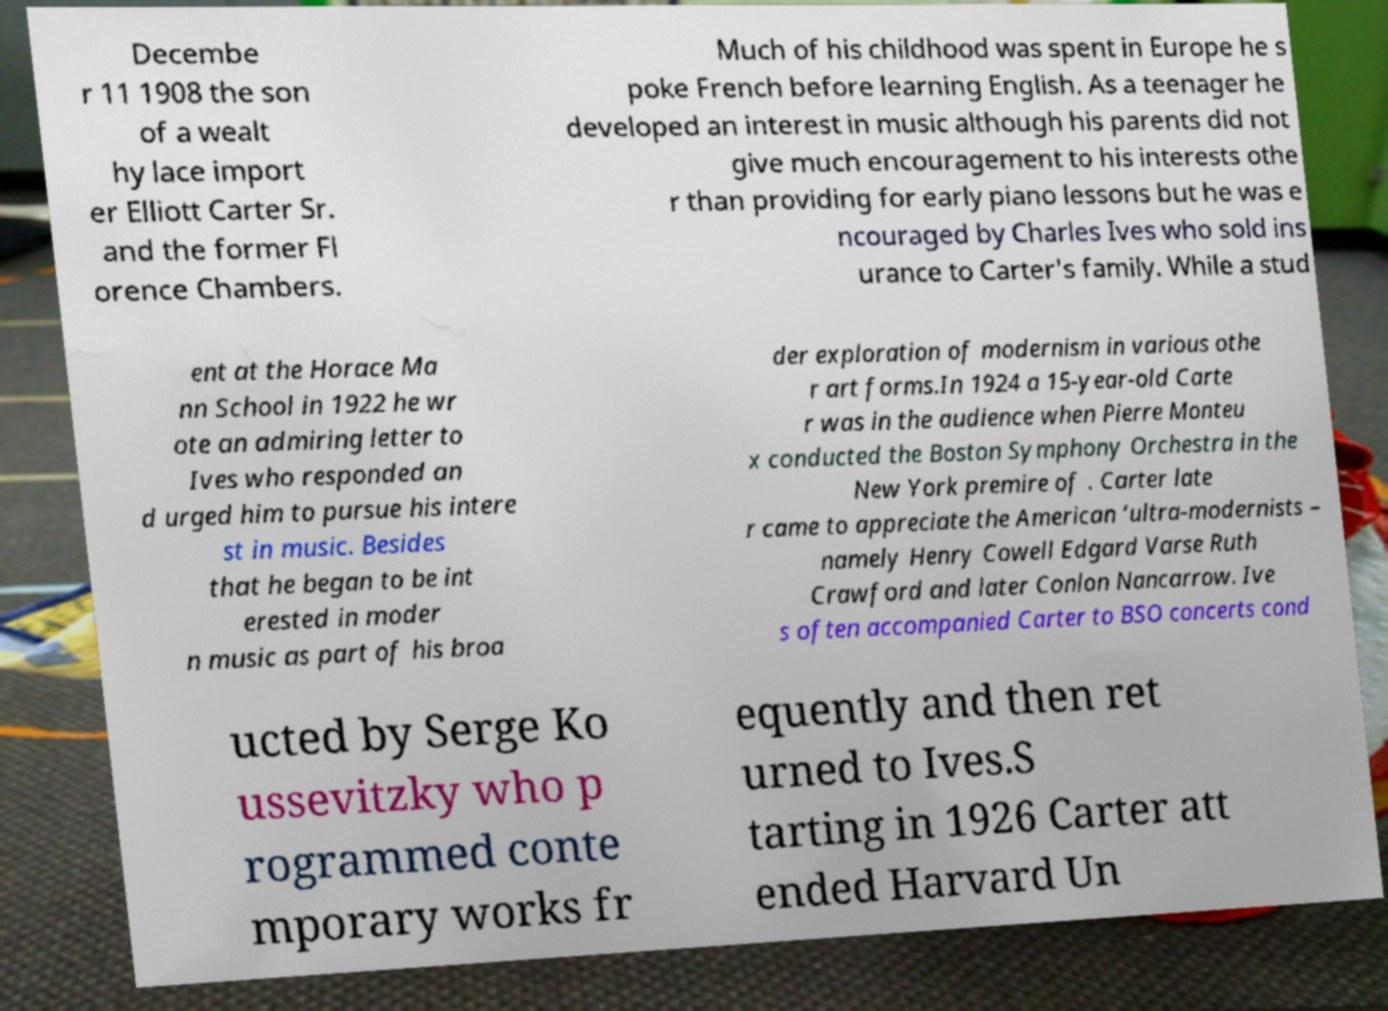Can you read and provide the text displayed in the image?This photo seems to have some interesting text. Can you extract and type it out for me? Decembe r 11 1908 the son of a wealt hy lace import er Elliott Carter Sr. and the former Fl orence Chambers. Much of his childhood was spent in Europe he s poke French before learning English. As a teenager he developed an interest in music although his parents did not give much encouragement to his interests othe r than providing for early piano lessons but he was e ncouraged by Charles Ives who sold ins urance to Carter's family. While a stud ent at the Horace Ma nn School in 1922 he wr ote an admiring letter to Ives who responded an d urged him to pursue his intere st in music. Besides that he began to be int erested in moder n music as part of his broa der exploration of modernism in various othe r art forms.In 1924 a 15-year-old Carte r was in the audience when Pierre Monteu x conducted the Boston Symphony Orchestra in the New York premire of . Carter late r came to appreciate the American ‘ultra-modernists – namely Henry Cowell Edgard Varse Ruth Crawford and later Conlon Nancarrow. Ive s often accompanied Carter to BSO concerts cond ucted by Serge Ko ussevitzky who p rogrammed conte mporary works fr equently and then ret urned to Ives.S tarting in 1926 Carter att ended Harvard Un 